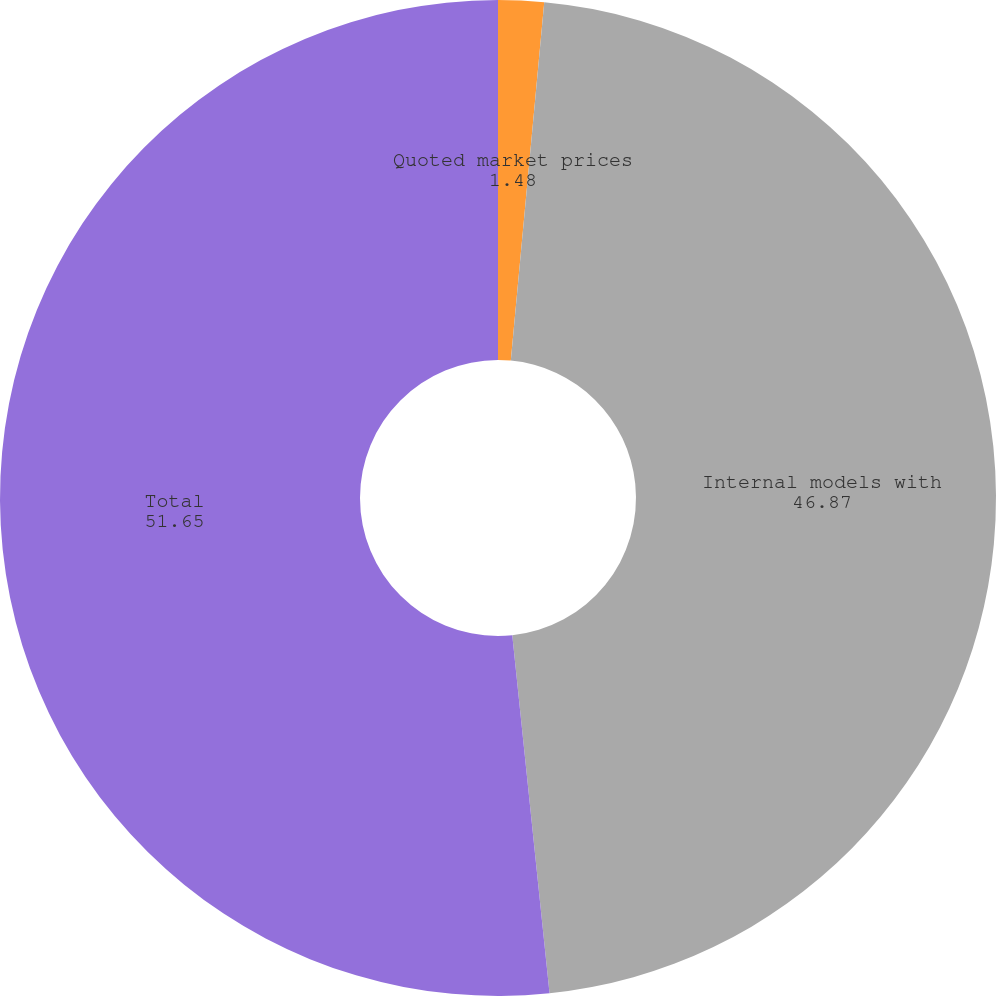Convert chart to OTSL. <chart><loc_0><loc_0><loc_500><loc_500><pie_chart><fcel>Quoted market prices<fcel>Internal models with<fcel>Total<nl><fcel>1.48%<fcel>46.87%<fcel>51.65%<nl></chart> 